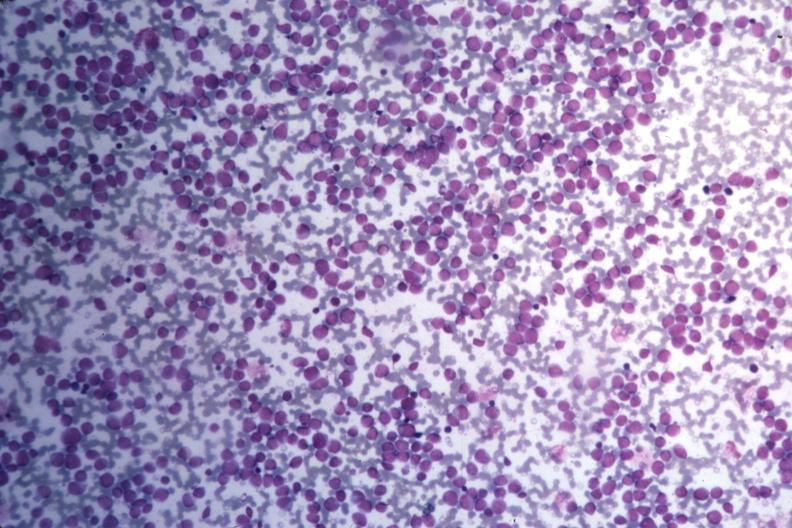what does this image show?
Answer the question using a single word or phrase. Med wrights stain many pleomorphic blast cells readily seen 